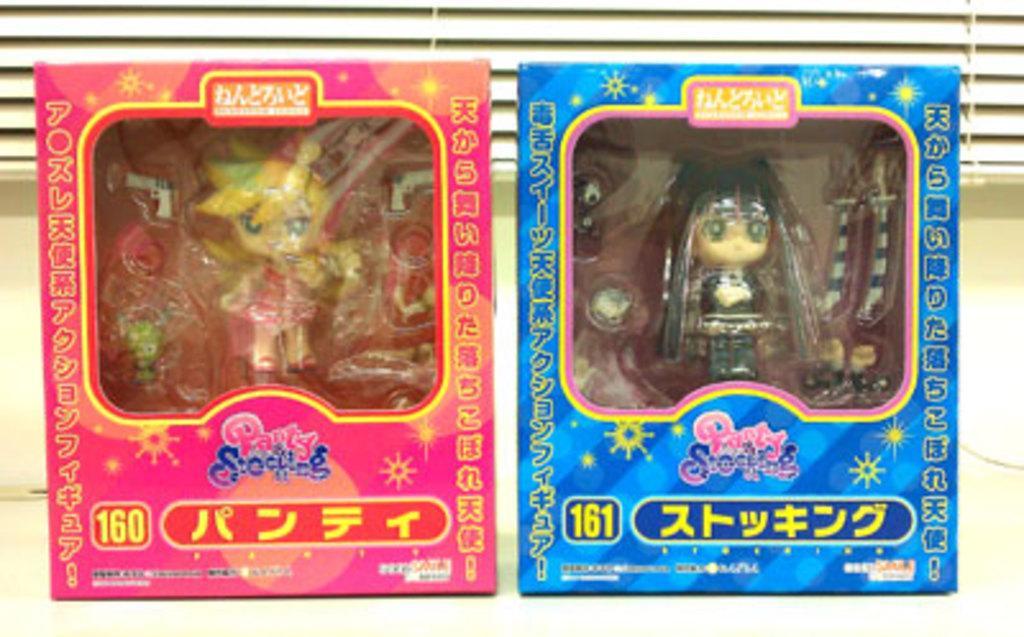Describe this image in one or two sentences. In this image there are two toy boxes one beside the other. In the toy boxes there are small toys. In the background there is a curtain. 